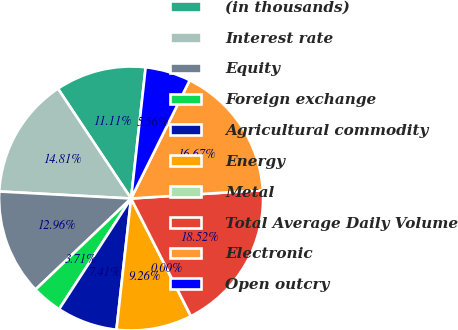Convert chart to OTSL. <chart><loc_0><loc_0><loc_500><loc_500><pie_chart><fcel>(in thousands)<fcel>Interest rate<fcel>Equity<fcel>Foreign exchange<fcel>Agricultural commodity<fcel>Energy<fcel>Metal<fcel>Total Average Daily Volume<fcel>Electronic<fcel>Open outcry<nl><fcel>11.11%<fcel>14.81%<fcel>12.96%<fcel>3.71%<fcel>7.41%<fcel>9.26%<fcel>0.0%<fcel>18.52%<fcel>16.67%<fcel>5.56%<nl></chart> 